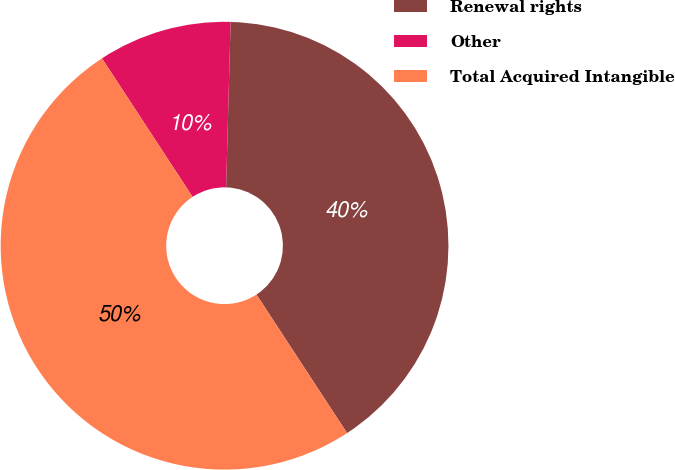Convert chart to OTSL. <chart><loc_0><loc_0><loc_500><loc_500><pie_chart><fcel>Renewal rights<fcel>Other<fcel>Total Acquired Intangible<nl><fcel>40.35%<fcel>9.65%<fcel>50.0%<nl></chart> 